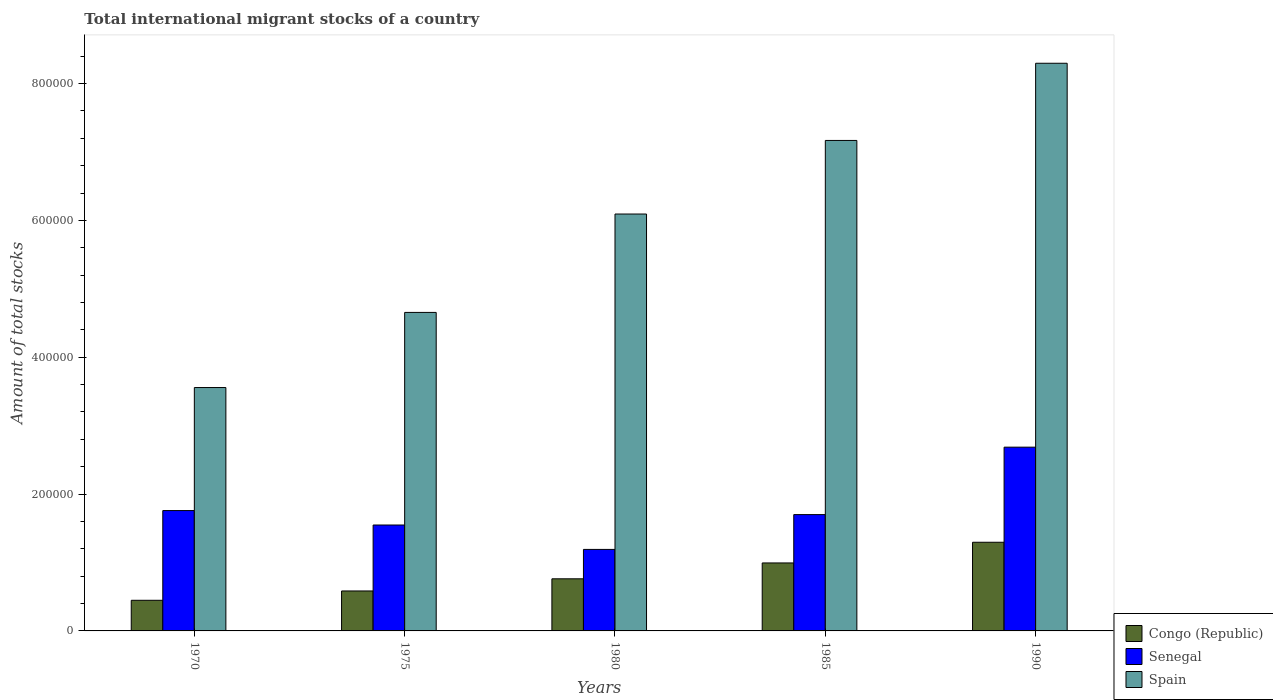Are the number of bars on each tick of the X-axis equal?
Ensure brevity in your answer.  Yes. How many bars are there on the 1st tick from the right?
Your answer should be very brief. 3. In how many cases, is the number of bars for a given year not equal to the number of legend labels?
Offer a very short reply. 0. What is the amount of total stocks in in Senegal in 1980?
Offer a very short reply. 1.19e+05. Across all years, what is the maximum amount of total stocks in in Senegal?
Your answer should be compact. 2.69e+05. Across all years, what is the minimum amount of total stocks in in Spain?
Keep it short and to the point. 3.56e+05. In which year was the amount of total stocks in in Spain minimum?
Your response must be concise. 1970. What is the total amount of total stocks in in Spain in the graph?
Make the answer very short. 2.98e+06. What is the difference between the amount of total stocks in in Senegal in 1980 and that in 1985?
Provide a succinct answer. -5.09e+04. What is the difference between the amount of total stocks in in Senegal in 1970 and the amount of total stocks in in Spain in 1980?
Offer a very short reply. -4.33e+05. What is the average amount of total stocks in in Spain per year?
Provide a succinct answer. 5.95e+05. In the year 1990, what is the difference between the amount of total stocks in in Senegal and amount of total stocks in in Spain?
Your answer should be very brief. -5.61e+05. In how many years, is the amount of total stocks in in Congo (Republic) greater than 760000?
Provide a short and direct response. 0. What is the ratio of the amount of total stocks in in Congo (Republic) in 1975 to that in 1985?
Offer a very short reply. 0.59. Is the amount of total stocks in in Spain in 1975 less than that in 1985?
Provide a succinct answer. Yes. Is the difference between the amount of total stocks in in Senegal in 1970 and 1980 greater than the difference between the amount of total stocks in in Spain in 1970 and 1980?
Give a very brief answer. Yes. What is the difference between the highest and the second highest amount of total stocks in in Spain?
Offer a terse response. 1.13e+05. What is the difference between the highest and the lowest amount of total stocks in in Senegal?
Keep it short and to the point. 1.49e+05. In how many years, is the amount of total stocks in in Senegal greater than the average amount of total stocks in in Senegal taken over all years?
Keep it short and to the point. 1. Is the sum of the amount of total stocks in in Senegal in 1980 and 1985 greater than the maximum amount of total stocks in in Congo (Republic) across all years?
Give a very brief answer. Yes. What does the 2nd bar from the left in 1985 represents?
Make the answer very short. Senegal. Is it the case that in every year, the sum of the amount of total stocks in in Senegal and amount of total stocks in in Spain is greater than the amount of total stocks in in Congo (Republic)?
Offer a very short reply. Yes. How many bars are there?
Your answer should be very brief. 15. What is the difference between two consecutive major ticks on the Y-axis?
Provide a short and direct response. 2.00e+05. Are the values on the major ticks of Y-axis written in scientific E-notation?
Keep it short and to the point. No. Does the graph contain any zero values?
Offer a very short reply. No. Does the graph contain grids?
Your answer should be compact. No. Where does the legend appear in the graph?
Offer a very short reply. Bottom right. How are the legend labels stacked?
Ensure brevity in your answer.  Vertical. What is the title of the graph?
Your response must be concise. Total international migrant stocks of a country. Does "Mongolia" appear as one of the legend labels in the graph?
Ensure brevity in your answer.  No. What is the label or title of the Y-axis?
Make the answer very short. Amount of total stocks. What is the Amount of total stocks of Congo (Republic) in 1970?
Offer a terse response. 4.48e+04. What is the Amount of total stocks of Senegal in 1970?
Your response must be concise. 1.76e+05. What is the Amount of total stocks in Spain in 1970?
Keep it short and to the point. 3.56e+05. What is the Amount of total stocks in Congo (Republic) in 1975?
Offer a terse response. 5.84e+04. What is the Amount of total stocks in Senegal in 1975?
Offer a very short reply. 1.55e+05. What is the Amount of total stocks in Spain in 1975?
Offer a very short reply. 4.66e+05. What is the Amount of total stocks in Congo (Republic) in 1980?
Give a very brief answer. 7.62e+04. What is the Amount of total stocks in Senegal in 1980?
Provide a succinct answer. 1.19e+05. What is the Amount of total stocks of Spain in 1980?
Your answer should be compact. 6.09e+05. What is the Amount of total stocks in Congo (Republic) in 1985?
Keep it short and to the point. 9.94e+04. What is the Amount of total stocks in Senegal in 1985?
Make the answer very short. 1.70e+05. What is the Amount of total stocks of Spain in 1985?
Keep it short and to the point. 7.17e+05. What is the Amount of total stocks in Congo (Republic) in 1990?
Offer a terse response. 1.30e+05. What is the Amount of total stocks in Senegal in 1990?
Provide a succinct answer. 2.69e+05. What is the Amount of total stocks in Spain in 1990?
Your answer should be compact. 8.30e+05. Across all years, what is the maximum Amount of total stocks of Congo (Republic)?
Make the answer very short. 1.30e+05. Across all years, what is the maximum Amount of total stocks in Senegal?
Offer a very short reply. 2.69e+05. Across all years, what is the maximum Amount of total stocks in Spain?
Provide a short and direct response. 8.30e+05. Across all years, what is the minimum Amount of total stocks of Congo (Republic)?
Ensure brevity in your answer.  4.48e+04. Across all years, what is the minimum Amount of total stocks of Senegal?
Offer a terse response. 1.19e+05. Across all years, what is the minimum Amount of total stocks of Spain?
Keep it short and to the point. 3.56e+05. What is the total Amount of total stocks in Congo (Republic) in the graph?
Provide a short and direct response. 4.08e+05. What is the total Amount of total stocks of Senegal in the graph?
Your answer should be very brief. 8.88e+05. What is the total Amount of total stocks in Spain in the graph?
Your answer should be compact. 2.98e+06. What is the difference between the Amount of total stocks in Congo (Republic) in 1970 and that in 1975?
Keep it short and to the point. -1.36e+04. What is the difference between the Amount of total stocks of Senegal in 1970 and that in 1975?
Ensure brevity in your answer.  2.11e+04. What is the difference between the Amount of total stocks of Spain in 1970 and that in 1975?
Offer a very short reply. -1.10e+05. What is the difference between the Amount of total stocks of Congo (Republic) in 1970 and that in 1980?
Ensure brevity in your answer.  -3.14e+04. What is the difference between the Amount of total stocks in Senegal in 1970 and that in 1980?
Make the answer very short. 5.68e+04. What is the difference between the Amount of total stocks in Spain in 1970 and that in 1980?
Make the answer very short. -2.54e+05. What is the difference between the Amount of total stocks in Congo (Republic) in 1970 and that in 1985?
Provide a short and direct response. -5.46e+04. What is the difference between the Amount of total stocks in Senegal in 1970 and that in 1985?
Your answer should be very brief. 5891. What is the difference between the Amount of total stocks in Spain in 1970 and that in 1985?
Provide a short and direct response. -3.61e+05. What is the difference between the Amount of total stocks of Congo (Republic) in 1970 and that in 1990?
Offer a terse response. -8.48e+04. What is the difference between the Amount of total stocks of Senegal in 1970 and that in 1990?
Your answer should be compact. -9.27e+04. What is the difference between the Amount of total stocks in Spain in 1970 and that in 1990?
Ensure brevity in your answer.  -4.74e+05. What is the difference between the Amount of total stocks in Congo (Republic) in 1975 and that in 1980?
Offer a very short reply. -1.78e+04. What is the difference between the Amount of total stocks of Senegal in 1975 and that in 1980?
Your answer should be very brief. 3.57e+04. What is the difference between the Amount of total stocks in Spain in 1975 and that in 1980?
Give a very brief answer. -1.44e+05. What is the difference between the Amount of total stocks in Congo (Republic) in 1975 and that in 1985?
Offer a terse response. -4.10e+04. What is the difference between the Amount of total stocks of Senegal in 1975 and that in 1985?
Give a very brief answer. -1.52e+04. What is the difference between the Amount of total stocks in Spain in 1975 and that in 1985?
Provide a succinct answer. -2.51e+05. What is the difference between the Amount of total stocks in Congo (Republic) in 1975 and that in 1990?
Offer a very short reply. -7.12e+04. What is the difference between the Amount of total stocks in Senegal in 1975 and that in 1990?
Provide a succinct answer. -1.14e+05. What is the difference between the Amount of total stocks of Spain in 1975 and that in 1990?
Your response must be concise. -3.64e+05. What is the difference between the Amount of total stocks of Congo (Republic) in 1980 and that in 1985?
Offer a terse response. -2.32e+04. What is the difference between the Amount of total stocks of Senegal in 1980 and that in 1985?
Keep it short and to the point. -5.09e+04. What is the difference between the Amount of total stocks of Spain in 1980 and that in 1985?
Your answer should be very brief. -1.08e+05. What is the difference between the Amount of total stocks of Congo (Republic) in 1980 and that in 1990?
Keep it short and to the point. -5.34e+04. What is the difference between the Amount of total stocks in Senegal in 1980 and that in 1990?
Keep it short and to the point. -1.49e+05. What is the difference between the Amount of total stocks in Spain in 1980 and that in 1990?
Keep it short and to the point. -2.20e+05. What is the difference between the Amount of total stocks in Congo (Republic) in 1985 and that in 1990?
Give a very brief answer. -3.02e+04. What is the difference between the Amount of total stocks in Senegal in 1985 and that in 1990?
Keep it short and to the point. -9.85e+04. What is the difference between the Amount of total stocks of Spain in 1985 and that in 1990?
Your answer should be very brief. -1.13e+05. What is the difference between the Amount of total stocks in Congo (Republic) in 1970 and the Amount of total stocks in Senegal in 1975?
Your answer should be very brief. -1.10e+05. What is the difference between the Amount of total stocks of Congo (Republic) in 1970 and the Amount of total stocks of Spain in 1975?
Your answer should be compact. -4.21e+05. What is the difference between the Amount of total stocks of Senegal in 1970 and the Amount of total stocks of Spain in 1975?
Your response must be concise. -2.90e+05. What is the difference between the Amount of total stocks of Congo (Republic) in 1970 and the Amount of total stocks of Senegal in 1980?
Your response must be concise. -7.44e+04. What is the difference between the Amount of total stocks in Congo (Republic) in 1970 and the Amount of total stocks in Spain in 1980?
Offer a very short reply. -5.65e+05. What is the difference between the Amount of total stocks of Senegal in 1970 and the Amount of total stocks of Spain in 1980?
Give a very brief answer. -4.33e+05. What is the difference between the Amount of total stocks of Congo (Republic) in 1970 and the Amount of total stocks of Senegal in 1985?
Offer a very short reply. -1.25e+05. What is the difference between the Amount of total stocks in Congo (Republic) in 1970 and the Amount of total stocks in Spain in 1985?
Your response must be concise. -6.72e+05. What is the difference between the Amount of total stocks in Senegal in 1970 and the Amount of total stocks in Spain in 1985?
Offer a terse response. -5.41e+05. What is the difference between the Amount of total stocks in Congo (Republic) in 1970 and the Amount of total stocks in Senegal in 1990?
Make the answer very short. -2.24e+05. What is the difference between the Amount of total stocks of Congo (Republic) in 1970 and the Amount of total stocks of Spain in 1990?
Offer a very short reply. -7.85e+05. What is the difference between the Amount of total stocks of Senegal in 1970 and the Amount of total stocks of Spain in 1990?
Make the answer very short. -6.54e+05. What is the difference between the Amount of total stocks in Congo (Republic) in 1975 and the Amount of total stocks in Senegal in 1980?
Your answer should be very brief. -6.07e+04. What is the difference between the Amount of total stocks of Congo (Republic) in 1975 and the Amount of total stocks of Spain in 1980?
Your answer should be very brief. -5.51e+05. What is the difference between the Amount of total stocks in Senegal in 1975 and the Amount of total stocks in Spain in 1980?
Offer a terse response. -4.55e+05. What is the difference between the Amount of total stocks of Congo (Republic) in 1975 and the Amount of total stocks of Senegal in 1985?
Ensure brevity in your answer.  -1.12e+05. What is the difference between the Amount of total stocks in Congo (Republic) in 1975 and the Amount of total stocks in Spain in 1985?
Give a very brief answer. -6.58e+05. What is the difference between the Amount of total stocks of Senegal in 1975 and the Amount of total stocks of Spain in 1985?
Your answer should be compact. -5.62e+05. What is the difference between the Amount of total stocks in Congo (Republic) in 1975 and the Amount of total stocks in Senegal in 1990?
Offer a very short reply. -2.10e+05. What is the difference between the Amount of total stocks in Congo (Republic) in 1975 and the Amount of total stocks in Spain in 1990?
Your answer should be compact. -7.71e+05. What is the difference between the Amount of total stocks of Senegal in 1975 and the Amount of total stocks of Spain in 1990?
Your response must be concise. -6.75e+05. What is the difference between the Amount of total stocks of Congo (Republic) in 1980 and the Amount of total stocks of Senegal in 1985?
Provide a succinct answer. -9.39e+04. What is the difference between the Amount of total stocks of Congo (Republic) in 1980 and the Amount of total stocks of Spain in 1985?
Give a very brief answer. -6.41e+05. What is the difference between the Amount of total stocks in Senegal in 1980 and the Amount of total stocks in Spain in 1985?
Offer a very short reply. -5.98e+05. What is the difference between the Amount of total stocks of Congo (Republic) in 1980 and the Amount of total stocks of Senegal in 1990?
Your answer should be very brief. -1.92e+05. What is the difference between the Amount of total stocks of Congo (Republic) in 1980 and the Amount of total stocks of Spain in 1990?
Offer a very short reply. -7.54e+05. What is the difference between the Amount of total stocks of Senegal in 1980 and the Amount of total stocks of Spain in 1990?
Your response must be concise. -7.11e+05. What is the difference between the Amount of total stocks in Congo (Republic) in 1985 and the Amount of total stocks in Senegal in 1990?
Provide a short and direct response. -1.69e+05. What is the difference between the Amount of total stocks in Congo (Republic) in 1985 and the Amount of total stocks in Spain in 1990?
Provide a short and direct response. -7.30e+05. What is the difference between the Amount of total stocks of Senegal in 1985 and the Amount of total stocks of Spain in 1990?
Ensure brevity in your answer.  -6.60e+05. What is the average Amount of total stocks of Congo (Republic) per year?
Your response must be concise. 8.17e+04. What is the average Amount of total stocks of Senegal per year?
Your answer should be compact. 1.78e+05. What is the average Amount of total stocks in Spain per year?
Offer a terse response. 5.95e+05. In the year 1970, what is the difference between the Amount of total stocks in Congo (Republic) and Amount of total stocks in Senegal?
Provide a short and direct response. -1.31e+05. In the year 1970, what is the difference between the Amount of total stocks of Congo (Republic) and Amount of total stocks of Spain?
Give a very brief answer. -3.11e+05. In the year 1970, what is the difference between the Amount of total stocks of Senegal and Amount of total stocks of Spain?
Give a very brief answer. -1.80e+05. In the year 1975, what is the difference between the Amount of total stocks of Congo (Republic) and Amount of total stocks of Senegal?
Offer a very short reply. -9.64e+04. In the year 1975, what is the difference between the Amount of total stocks of Congo (Republic) and Amount of total stocks of Spain?
Keep it short and to the point. -4.07e+05. In the year 1975, what is the difference between the Amount of total stocks of Senegal and Amount of total stocks of Spain?
Make the answer very short. -3.11e+05. In the year 1980, what is the difference between the Amount of total stocks in Congo (Republic) and Amount of total stocks in Senegal?
Your answer should be compact. -4.30e+04. In the year 1980, what is the difference between the Amount of total stocks of Congo (Republic) and Amount of total stocks of Spain?
Offer a very short reply. -5.33e+05. In the year 1980, what is the difference between the Amount of total stocks of Senegal and Amount of total stocks of Spain?
Your answer should be very brief. -4.90e+05. In the year 1985, what is the difference between the Amount of total stocks in Congo (Republic) and Amount of total stocks in Senegal?
Provide a succinct answer. -7.07e+04. In the year 1985, what is the difference between the Amount of total stocks of Congo (Republic) and Amount of total stocks of Spain?
Keep it short and to the point. -6.18e+05. In the year 1985, what is the difference between the Amount of total stocks of Senegal and Amount of total stocks of Spain?
Your response must be concise. -5.47e+05. In the year 1990, what is the difference between the Amount of total stocks in Congo (Republic) and Amount of total stocks in Senegal?
Your response must be concise. -1.39e+05. In the year 1990, what is the difference between the Amount of total stocks of Congo (Republic) and Amount of total stocks of Spain?
Offer a very short reply. -7.00e+05. In the year 1990, what is the difference between the Amount of total stocks in Senegal and Amount of total stocks in Spain?
Keep it short and to the point. -5.61e+05. What is the ratio of the Amount of total stocks of Congo (Republic) in 1970 to that in 1975?
Your answer should be compact. 0.77. What is the ratio of the Amount of total stocks of Senegal in 1970 to that in 1975?
Your answer should be very brief. 1.14. What is the ratio of the Amount of total stocks in Spain in 1970 to that in 1975?
Provide a short and direct response. 0.76. What is the ratio of the Amount of total stocks of Congo (Republic) in 1970 to that in 1980?
Offer a terse response. 0.59. What is the ratio of the Amount of total stocks of Senegal in 1970 to that in 1980?
Make the answer very short. 1.48. What is the ratio of the Amount of total stocks of Spain in 1970 to that in 1980?
Keep it short and to the point. 0.58. What is the ratio of the Amount of total stocks in Congo (Republic) in 1970 to that in 1985?
Your response must be concise. 0.45. What is the ratio of the Amount of total stocks of Senegal in 1970 to that in 1985?
Provide a succinct answer. 1.03. What is the ratio of the Amount of total stocks of Spain in 1970 to that in 1985?
Provide a succinct answer. 0.5. What is the ratio of the Amount of total stocks of Congo (Republic) in 1970 to that in 1990?
Offer a terse response. 0.35. What is the ratio of the Amount of total stocks of Senegal in 1970 to that in 1990?
Offer a terse response. 0.66. What is the ratio of the Amount of total stocks in Spain in 1970 to that in 1990?
Your response must be concise. 0.43. What is the ratio of the Amount of total stocks of Congo (Republic) in 1975 to that in 1980?
Offer a very short reply. 0.77. What is the ratio of the Amount of total stocks of Senegal in 1975 to that in 1980?
Provide a short and direct response. 1.3. What is the ratio of the Amount of total stocks of Spain in 1975 to that in 1980?
Provide a short and direct response. 0.76. What is the ratio of the Amount of total stocks in Congo (Republic) in 1975 to that in 1985?
Make the answer very short. 0.59. What is the ratio of the Amount of total stocks of Senegal in 1975 to that in 1985?
Your answer should be compact. 0.91. What is the ratio of the Amount of total stocks in Spain in 1975 to that in 1985?
Your response must be concise. 0.65. What is the ratio of the Amount of total stocks in Congo (Republic) in 1975 to that in 1990?
Make the answer very short. 0.45. What is the ratio of the Amount of total stocks of Senegal in 1975 to that in 1990?
Give a very brief answer. 0.58. What is the ratio of the Amount of total stocks of Spain in 1975 to that in 1990?
Your answer should be compact. 0.56. What is the ratio of the Amount of total stocks in Congo (Republic) in 1980 to that in 1985?
Your answer should be very brief. 0.77. What is the ratio of the Amount of total stocks in Senegal in 1980 to that in 1985?
Your response must be concise. 0.7. What is the ratio of the Amount of total stocks of Spain in 1980 to that in 1985?
Make the answer very short. 0.85. What is the ratio of the Amount of total stocks in Congo (Republic) in 1980 to that in 1990?
Your response must be concise. 0.59. What is the ratio of the Amount of total stocks of Senegal in 1980 to that in 1990?
Offer a terse response. 0.44. What is the ratio of the Amount of total stocks of Spain in 1980 to that in 1990?
Your response must be concise. 0.73. What is the ratio of the Amount of total stocks in Congo (Republic) in 1985 to that in 1990?
Your answer should be very brief. 0.77. What is the ratio of the Amount of total stocks in Senegal in 1985 to that in 1990?
Offer a very short reply. 0.63. What is the ratio of the Amount of total stocks in Spain in 1985 to that in 1990?
Make the answer very short. 0.86. What is the difference between the highest and the second highest Amount of total stocks of Congo (Republic)?
Give a very brief answer. 3.02e+04. What is the difference between the highest and the second highest Amount of total stocks in Senegal?
Offer a terse response. 9.27e+04. What is the difference between the highest and the second highest Amount of total stocks of Spain?
Give a very brief answer. 1.13e+05. What is the difference between the highest and the lowest Amount of total stocks in Congo (Republic)?
Provide a succinct answer. 8.48e+04. What is the difference between the highest and the lowest Amount of total stocks in Senegal?
Provide a short and direct response. 1.49e+05. What is the difference between the highest and the lowest Amount of total stocks of Spain?
Your answer should be very brief. 4.74e+05. 